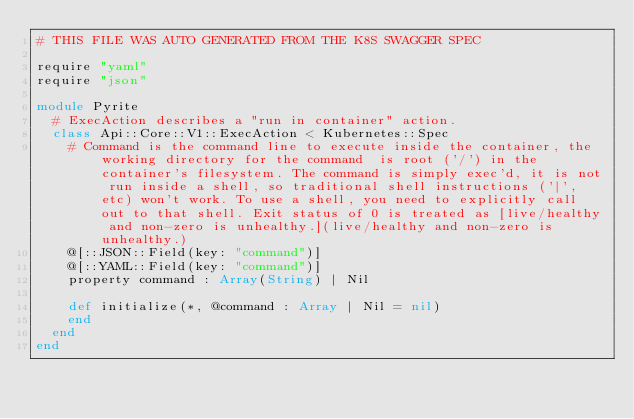<code> <loc_0><loc_0><loc_500><loc_500><_Crystal_># THIS FILE WAS AUTO GENERATED FROM THE K8S SWAGGER SPEC

require "yaml"
require "json"

module Pyrite
  # ExecAction describes a "run in container" action.
  class Api::Core::V1::ExecAction < Kubernetes::Spec
    # Command is the command line to execute inside the container, the working directory for the command  is root ('/') in the container's filesystem. The command is simply exec'd, it is not run inside a shell, so traditional shell instructions ('|', etc) won't work. To use a shell, you need to explicitly call out to that shell. Exit status of 0 is treated as [live/healthy and non-zero is unhealthy.](live/healthy and non-zero is unhealthy.)
    @[::JSON::Field(key: "command")]
    @[::YAML::Field(key: "command")]
    property command : Array(String) | Nil

    def initialize(*, @command : Array | Nil = nil)
    end
  end
end
</code> 